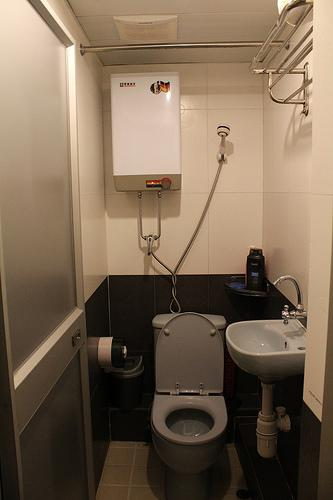Question: where is the toilet?
Choices:
A. In the bathroom.
B. On the boat.
C. On the plane.
D. Outside.
Answer with the letter. Answer: A Question: what color is the toilet?
Choices:
A. White.
B. Grey.
C. Black.
D. Yellow.
Answer with the letter. Answer: B Question: why is the toilet there?
Choices:
A. To take waste.
B. For cleanliness.
C. It is a bathroom.
D. For sanitation.
Answer with the letter. Answer: C Question: what is above the toilet?
Choices:
A. A picture.
B. A tank.
C. Water.
D. The ceiling.
Answer with the letter. Answer: B 